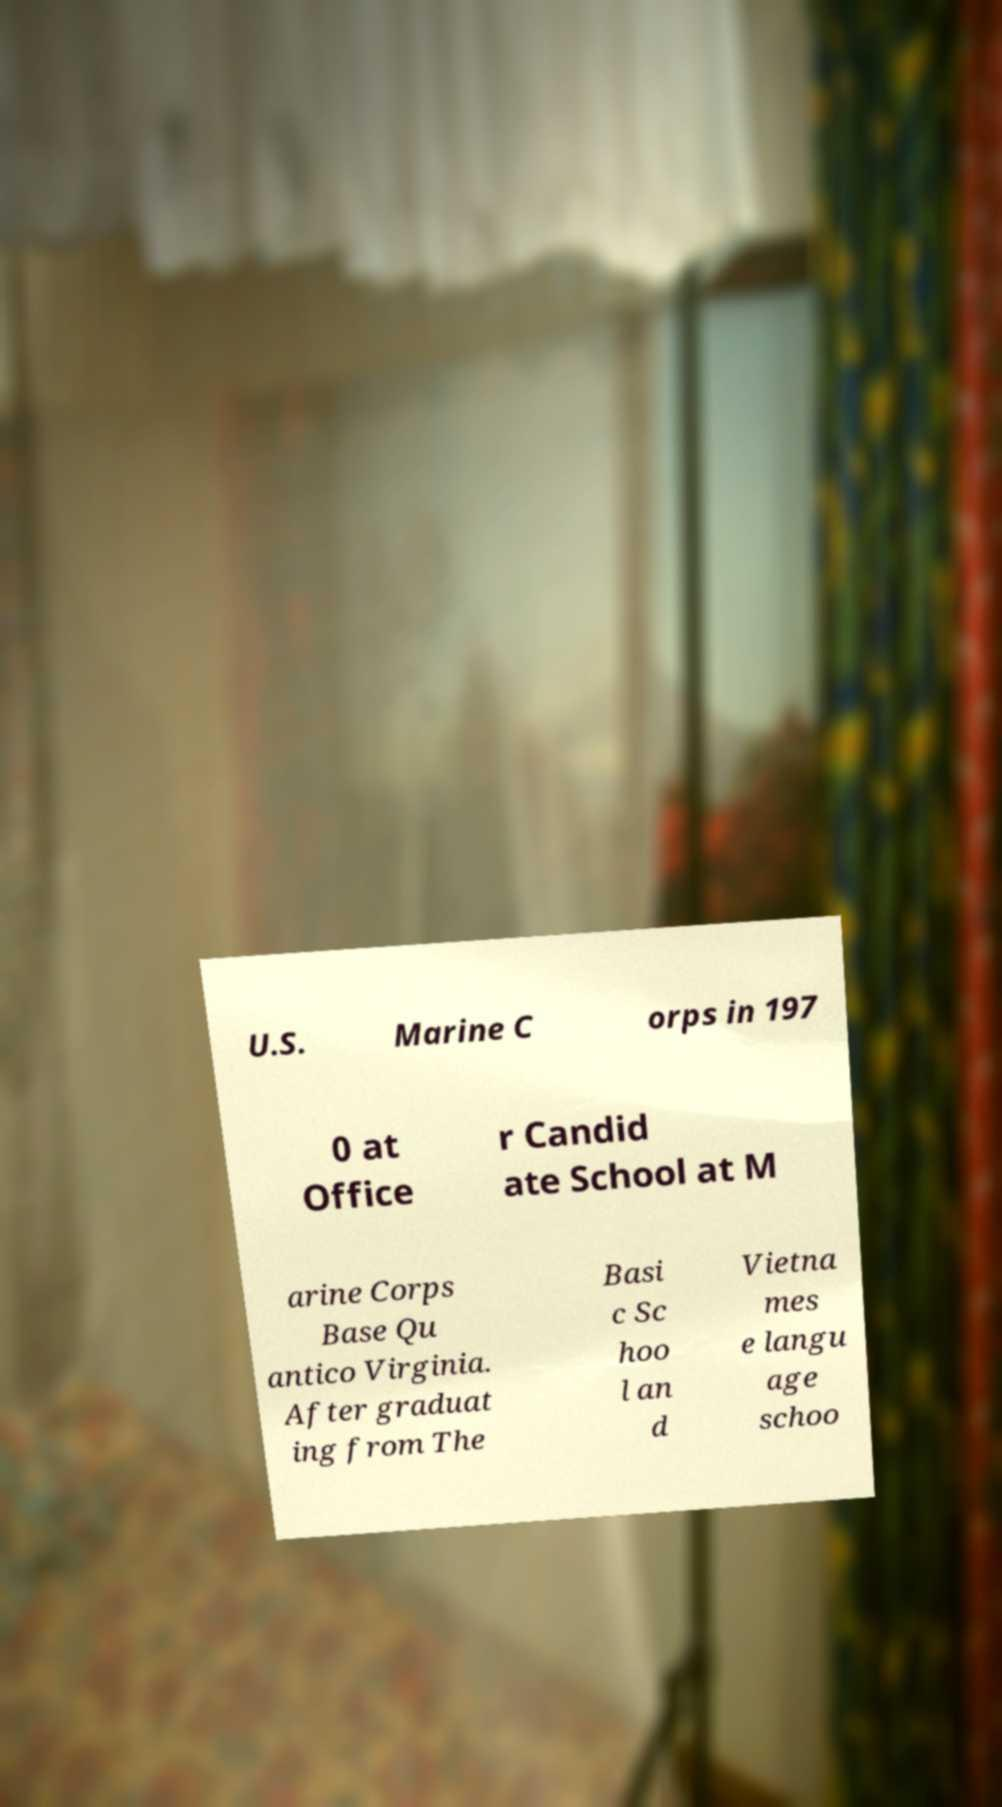For documentation purposes, I need the text within this image transcribed. Could you provide that? U.S. Marine C orps in 197 0 at Office r Candid ate School at M arine Corps Base Qu antico Virginia. After graduat ing from The Basi c Sc hoo l an d Vietna mes e langu age schoo 